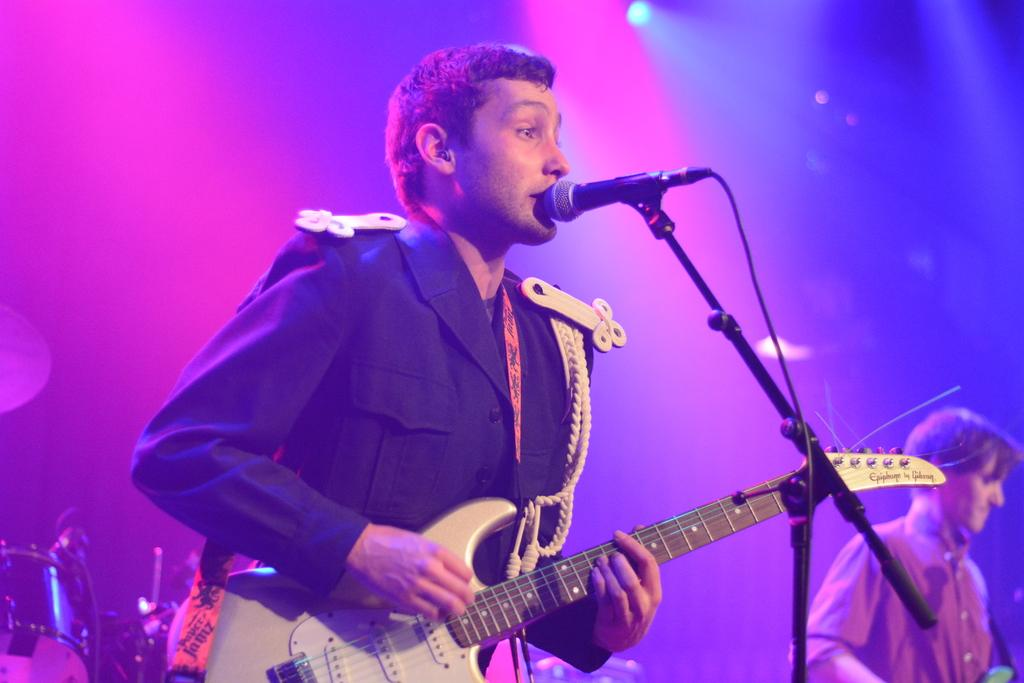What is the person in the image wearing? The person is wearing a black dress. What is the person holding in the image? The person is holding a guitar. What is the person doing with the guitar? The person is playing the guitar. What other musical instrument can be seen in the image? There is a drum in the image. Who is playing the drum? The other person in the image is playing the drum. What type of animal is sitting on the person's head in the image? There is no animal present on the person's head in the image. 